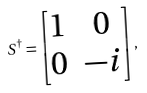Convert formula to latex. <formula><loc_0><loc_0><loc_500><loc_500>S ^ { \dagger } = \begin{bmatrix} 1 & 0 \\ 0 & - i \end{bmatrix} ,</formula> 